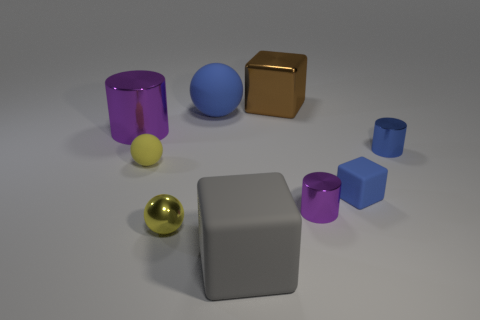Subtract all cylinders. How many objects are left? 6 Subtract 0 gray spheres. How many objects are left? 9 Subtract all large red metallic spheres. Subtract all purple cylinders. How many objects are left? 7 Add 4 small metal spheres. How many small metal spheres are left? 5 Add 3 big gray shiny objects. How many big gray shiny objects exist? 3 